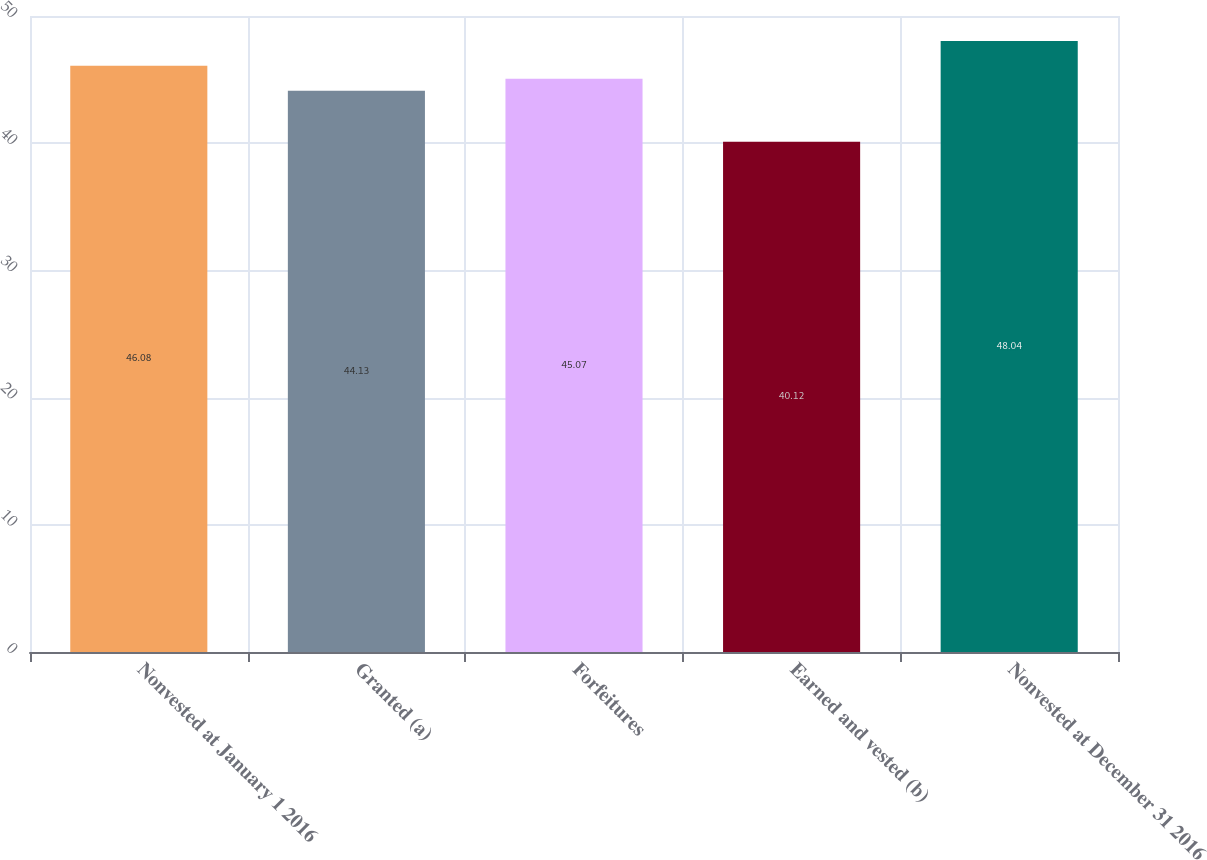<chart> <loc_0><loc_0><loc_500><loc_500><bar_chart><fcel>Nonvested at January 1 2016<fcel>Granted (a)<fcel>Forfeitures<fcel>Earned and vested (b)<fcel>Nonvested at December 31 2016<nl><fcel>46.08<fcel>44.13<fcel>45.07<fcel>40.12<fcel>48.04<nl></chart> 